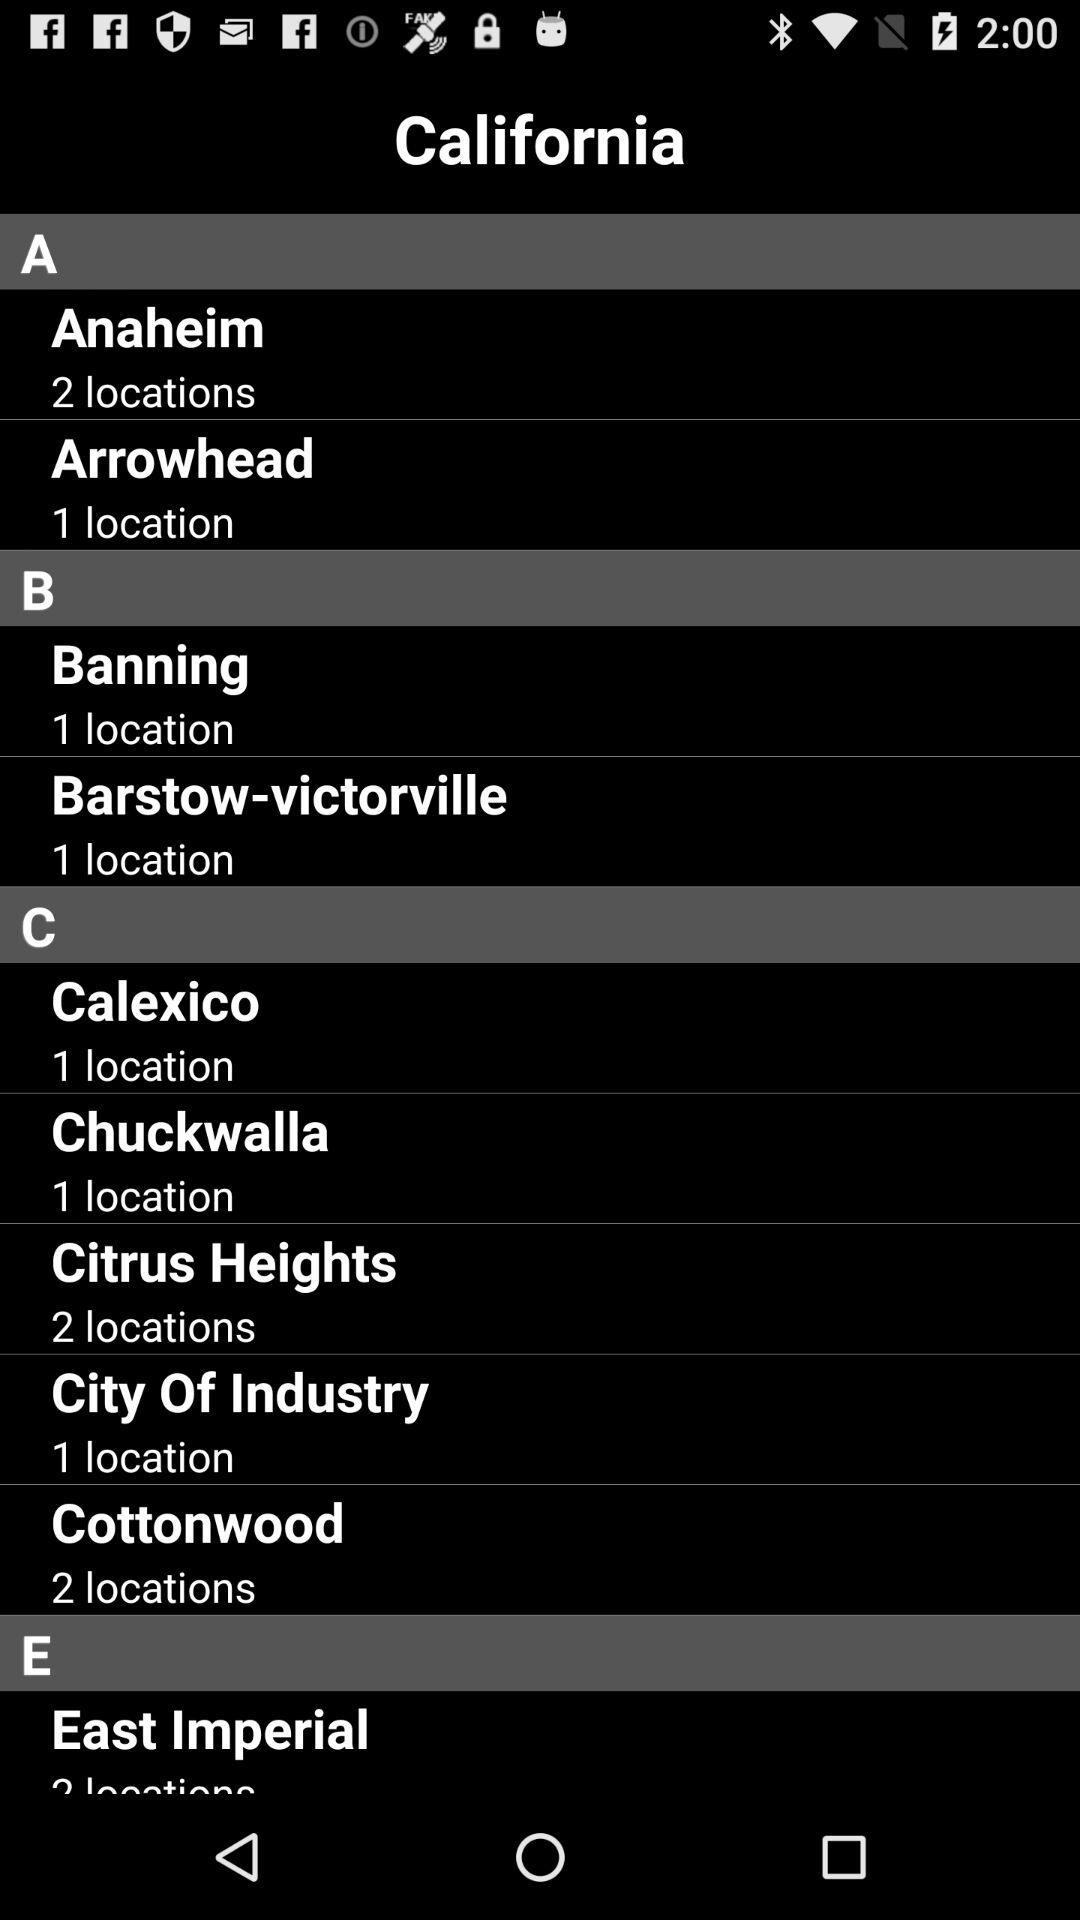What is the number of locations in Arrowhead? The number of locations in Arrowhead is 1. 